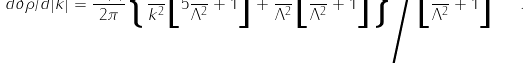<formula> <loc_0><loc_0><loc_500><loc_500>d \delta \rho / d | k | = \frac { V ( x ) } { 2 \pi } \Big { \{ } \frac { 1 } { k ^ { 2 } } \Big { [ } 5 \frac { k ^ { 2 } } { \Lambda ^ { 2 } } + 1 \Big { ] } + \frac { 1 } { \Lambda ^ { 2 } } \Big { [ } \frac { k ^ { 2 } } { \Lambda ^ { 2 } } + 1 \Big { ] } \Big { \} } \Big { / } \Big { [ } \frac { k ^ { 2 } } { \Lambda ^ { 2 } } + 1 \Big { ] } ^ { 3 } \ \ .</formula> 